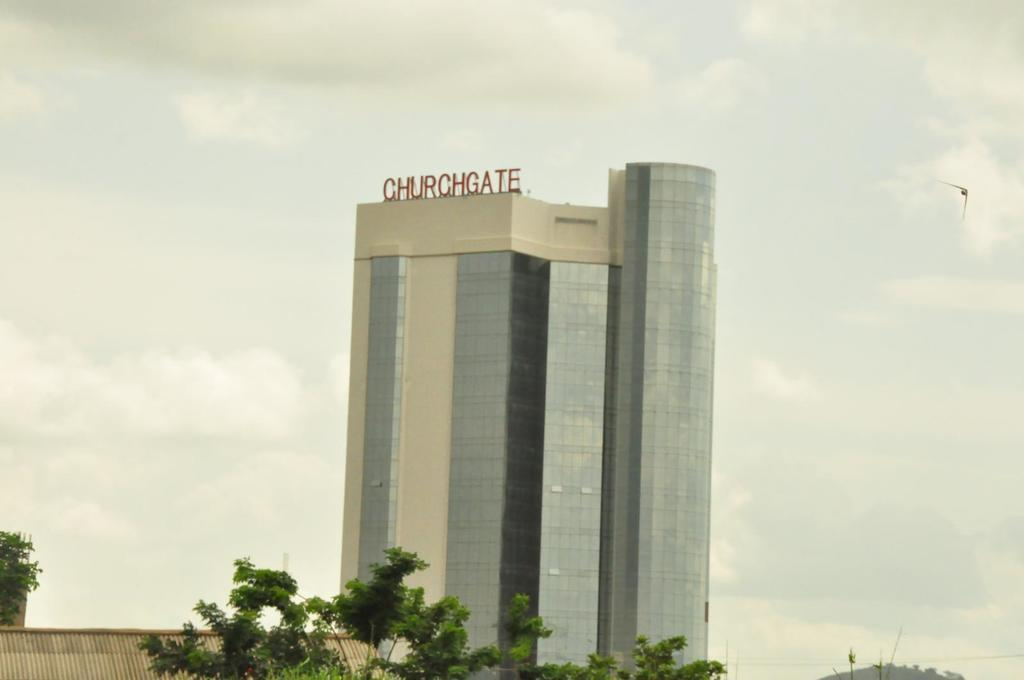What type of building is shown in the image? There is a building made of glass in the image. What else can be seen in the image besides the building? Text is visible in the image, as well as trees and a bird flying. How would you describe the weather in the image? The sky is cloudy in the image. Can you describe the bird in the image? A bird is flying in the image. Where are the dinosaurs hiding in the image? There are no dinosaurs present in the image. What type of butter is being used in the image? There is no butter present in the image. 